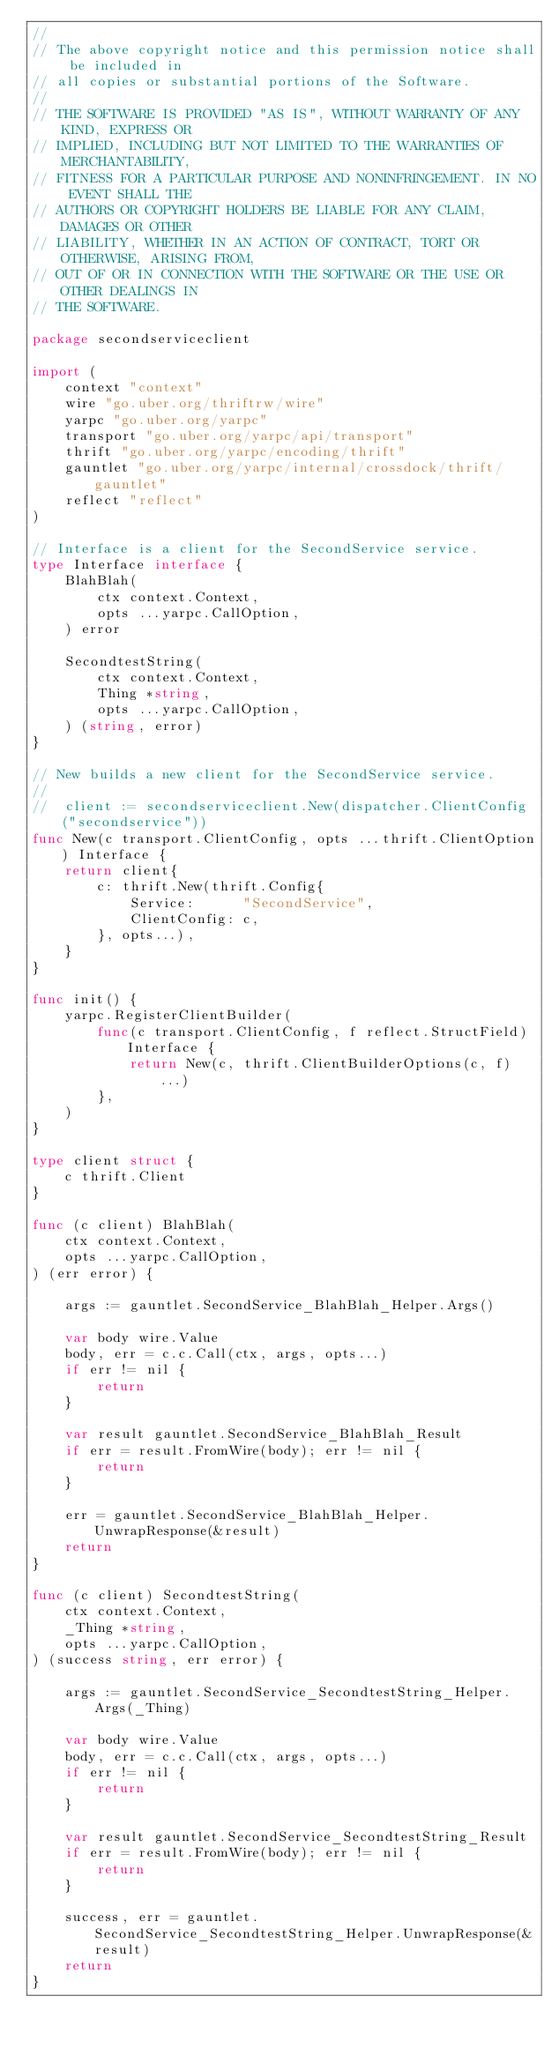Convert code to text. <code><loc_0><loc_0><loc_500><loc_500><_Go_>//
// The above copyright notice and this permission notice shall be included in
// all copies or substantial portions of the Software.
//
// THE SOFTWARE IS PROVIDED "AS IS", WITHOUT WARRANTY OF ANY KIND, EXPRESS OR
// IMPLIED, INCLUDING BUT NOT LIMITED TO THE WARRANTIES OF MERCHANTABILITY,
// FITNESS FOR A PARTICULAR PURPOSE AND NONINFRINGEMENT. IN NO EVENT SHALL THE
// AUTHORS OR COPYRIGHT HOLDERS BE LIABLE FOR ANY CLAIM, DAMAGES OR OTHER
// LIABILITY, WHETHER IN AN ACTION OF CONTRACT, TORT OR OTHERWISE, ARISING FROM,
// OUT OF OR IN CONNECTION WITH THE SOFTWARE OR THE USE OR OTHER DEALINGS IN
// THE SOFTWARE.

package secondserviceclient

import (
	context "context"
	wire "go.uber.org/thriftrw/wire"
	yarpc "go.uber.org/yarpc"
	transport "go.uber.org/yarpc/api/transport"
	thrift "go.uber.org/yarpc/encoding/thrift"
	gauntlet "go.uber.org/yarpc/internal/crossdock/thrift/gauntlet"
	reflect "reflect"
)

// Interface is a client for the SecondService service.
type Interface interface {
	BlahBlah(
		ctx context.Context,
		opts ...yarpc.CallOption,
	) error

	SecondtestString(
		ctx context.Context,
		Thing *string,
		opts ...yarpc.CallOption,
	) (string, error)
}

// New builds a new client for the SecondService service.
//
// 	client := secondserviceclient.New(dispatcher.ClientConfig("secondservice"))
func New(c transport.ClientConfig, opts ...thrift.ClientOption) Interface {
	return client{
		c: thrift.New(thrift.Config{
			Service:      "SecondService",
			ClientConfig: c,
		}, opts...),
	}
}

func init() {
	yarpc.RegisterClientBuilder(
		func(c transport.ClientConfig, f reflect.StructField) Interface {
			return New(c, thrift.ClientBuilderOptions(c, f)...)
		},
	)
}

type client struct {
	c thrift.Client
}

func (c client) BlahBlah(
	ctx context.Context,
	opts ...yarpc.CallOption,
) (err error) {

	args := gauntlet.SecondService_BlahBlah_Helper.Args()

	var body wire.Value
	body, err = c.c.Call(ctx, args, opts...)
	if err != nil {
		return
	}

	var result gauntlet.SecondService_BlahBlah_Result
	if err = result.FromWire(body); err != nil {
		return
	}

	err = gauntlet.SecondService_BlahBlah_Helper.UnwrapResponse(&result)
	return
}

func (c client) SecondtestString(
	ctx context.Context,
	_Thing *string,
	opts ...yarpc.CallOption,
) (success string, err error) {

	args := gauntlet.SecondService_SecondtestString_Helper.Args(_Thing)

	var body wire.Value
	body, err = c.c.Call(ctx, args, opts...)
	if err != nil {
		return
	}

	var result gauntlet.SecondService_SecondtestString_Result
	if err = result.FromWire(body); err != nil {
		return
	}

	success, err = gauntlet.SecondService_SecondtestString_Helper.UnwrapResponse(&result)
	return
}
</code> 